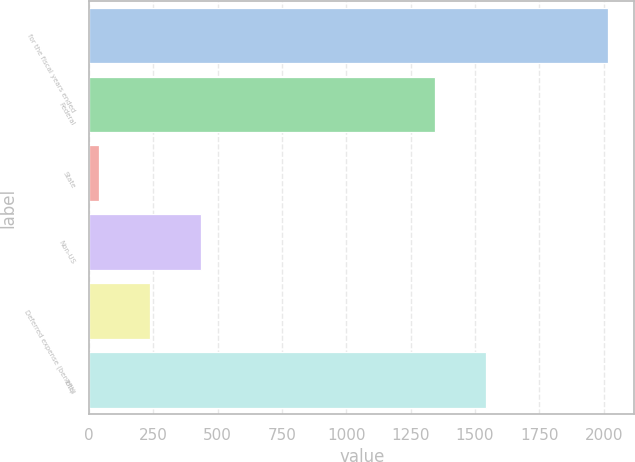<chart> <loc_0><loc_0><loc_500><loc_500><bar_chart><fcel>for the fiscal years ended<fcel>Federal<fcel>State<fcel>Non-US<fcel>Deferred expense (benefit)<fcel>Total<nl><fcel>2018<fcel>1343.7<fcel>38<fcel>434<fcel>236<fcel>1541.7<nl></chart> 